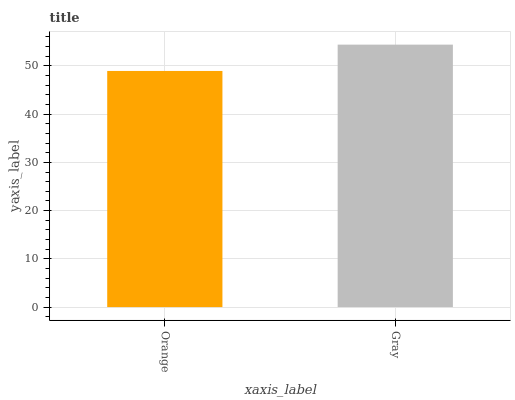Is Orange the minimum?
Answer yes or no. Yes. Is Gray the maximum?
Answer yes or no. Yes. Is Gray the minimum?
Answer yes or no. No. Is Gray greater than Orange?
Answer yes or no. Yes. Is Orange less than Gray?
Answer yes or no. Yes. Is Orange greater than Gray?
Answer yes or no. No. Is Gray less than Orange?
Answer yes or no. No. Is Gray the high median?
Answer yes or no. Yes. Is Orange the low median?
Answer yes or no. Yes. Is Orange the high median?
Answer yes or no. No. Is Gray the low median?
Answer yes or no. No. 